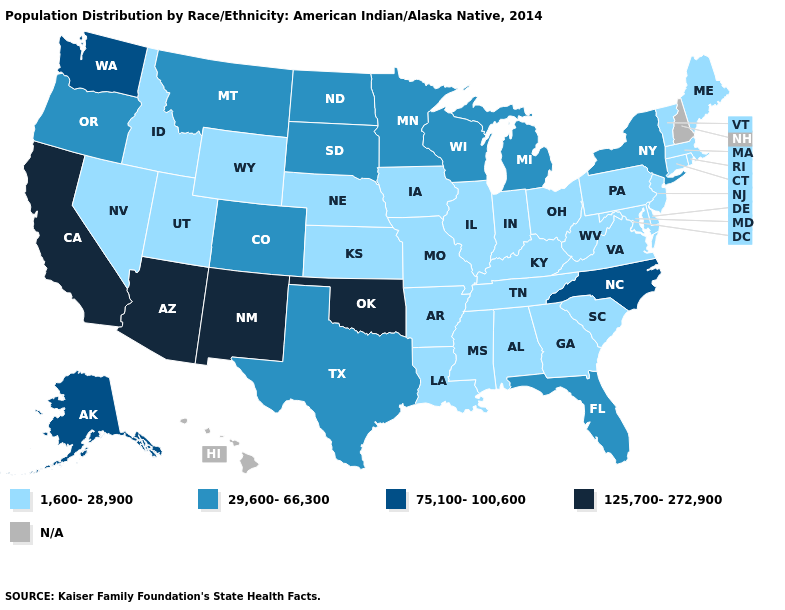Which states hav the highest value in the MidWest?
Be succinct. Michigan, Minnesota, North Dakota, South Dakota, Wisconsin. Which states have the lowest value in the USA?
Give a very brief answer. Alabama, Arkansas, Connecticut, Delaware, Georgia, Idaho, Illinois, Indiana, Iowa, Kansas, Kentucky, Louisiana, Maine, Maryland, Massachusetts, Mississippi, Missouri, Nebraska, Nevada, New Jersey, Ohio, Pennsylvania, Rhode Island, South Carolina, Tennessee, Utah, Vermont, Virginia, West Virginia, Wyoming. What is the value of Oklahoma?
Give a very brief answer. 125,700-272,900. What is the value of Illinois?
Answer briefly. 1,600-28,900. What is the value of Wisconsin?
Keep it brief. 29,600-66,300. What is the lowest value in the USA?
Keep it brief. 1,600-28,900. What is the value of Nebraska?
Keep it brief. 1,600-28,900. What is the highest value in states that border Georgia?
Answer briefly. 75,100-100,600. What is the value of Delaware?
Keep it brief. 1,600-28,900. Does Minnesota have the lowest value in the MidWest?
Short answer required. No. What is the value of Maryland?
Short answer required. 1,600-28,900. Name the states that have a value in the range 1,600-28,900?
Write a very short answer. Alabama, Arkansas, Connecticut, Delaware, Georgia, Idaho, Illinois, Indiana, Iowa, Kansas, Kentucky, Louisiana, Maine, Maryland, Massachusetts, Mississippi, Missouri, Nebraska, Nevada, New Jersey, Ohio, Pennsylvania, Rhode Island, South Carolina, Tennessee, Utah, Vermont, Virginia, West Virginia, Wyoming. What is the value of Alaska?
Answer briefly. 75,100-100,600. What is the value of Indiana?
Keep it brief. 1,600-28,900. Does Washington have the highest value in the West?
Give a very brief answer. No. 